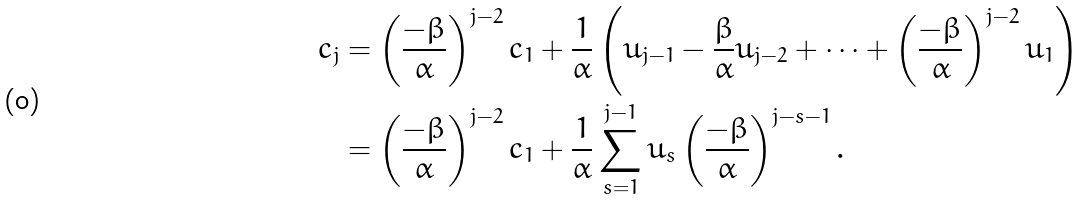<formula> <loc_0><loc_0><loc_500><loc_500>c _ { j } & = \left ( \frac { - \beta } { \alpha } \right ) ^ { j - 2 } c _ { 1 } + \frac { 1 } { \alpha } \left ( u _ { j - 1 } - \frac { \beta } { \alpha } u _ { j - 2 } + \cdots + \left ( \frac { - \beta } { \alpha } \right ) ^ { j - 2 } u _ { 1 } \right ) \\ & = \left ( \frac { - \beta } { \alpha } \right ) ^ { j - 2 } c _ { 1 } + \frac { 1 } { \alpha } \sum _ { s = 1 } ^ { j - 1 } u _ { s } \left ( \frac { - \beta } { \alpha } \right ) ^ { j - s - 1 } .</formula> 